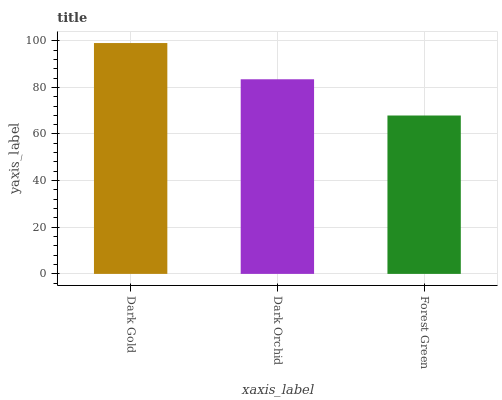Is Forest Green the minimum?
Answer yes or no. Yes. Is Dark Gold the maximum?
Answer yes or no. Yes. Is Dark Orchid the minimum?
Answer yes or no. No. Is Dark Orchid the maximum?
Answer yes or no. No. Is Dark Gold greater than Dark Orchid?
Answer yes or no. Yes. Is Dark Orchid less than Dark Gold?
Answer yes or no. Yes. Is Dark Orchid greater than Dark Gold?
Answer yes or no. No. Is Dark Gold less than Dark Orchid?
Answer yes or no. No. Is Dark Orchid the high median?
Answer yes or no. Yes. Is Dark Orchid the low median?
Answer yes or no. Yes. Is Forest Green the high median?
Answer yes or no. No. Is Forest Green the low median?
Answer yes or no. No. 